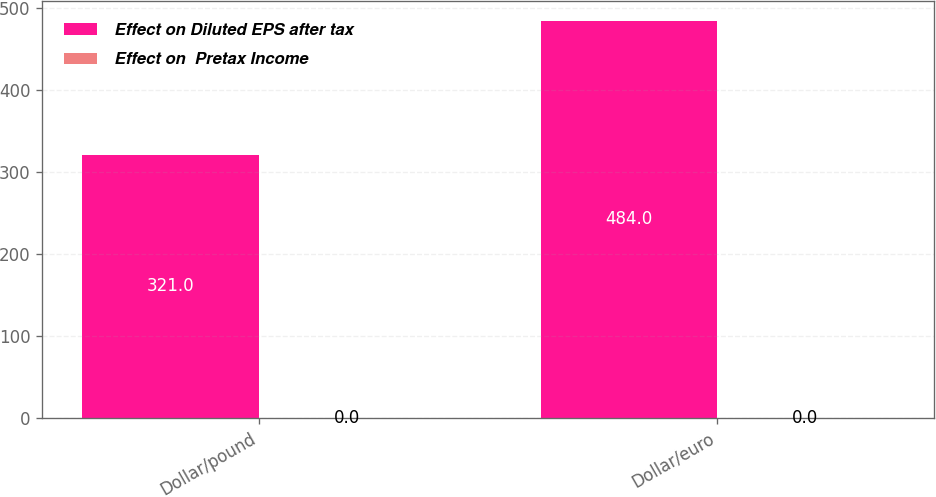<chart> <loc_0><loc_0><loc_500><loc_500><stacked_bar_chart><ecel><fcel>Dollar/pound<fcel>Dollar/euro<nl><fcel>Effect on Diluted EPS after tax<fcel>321<fcel>484<nl><fcel>Effect on  Pretax Income<fcel>0<fcel>0<nl></chart> 